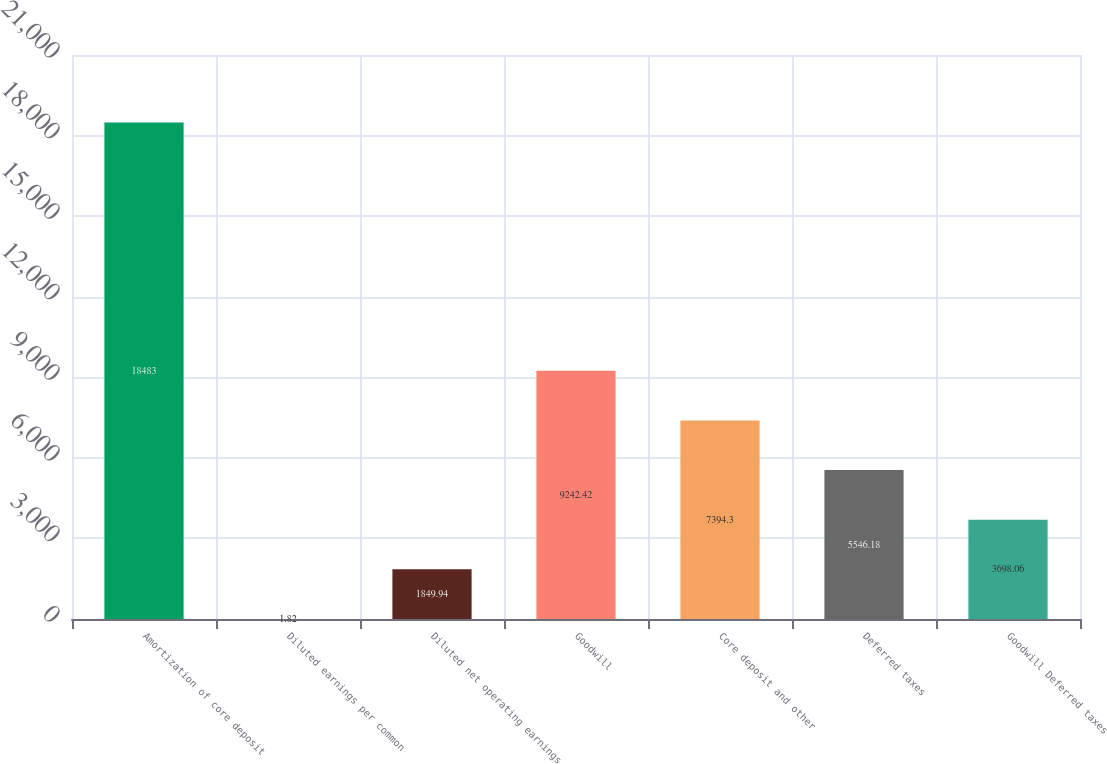Convert chart to OTSL. <chart><loc_0><loc_0><loc_500><loc_500><bar_chart><fcel>Amortization of core deposit<fcel>Diluted earnings per common<fcel>Diluted net operating earnings<fcel>Goodwill<fcel>Core deposit and other<fcel>Deferred taxes<fcel>Goodwill Deferred taxes<nl><fcel>18483<fcel>1.82<fcel>1849.94<fcel>9242.42<fcel>7394.3<fcel>5546.18<fcel>3698.06<nl></chart> 